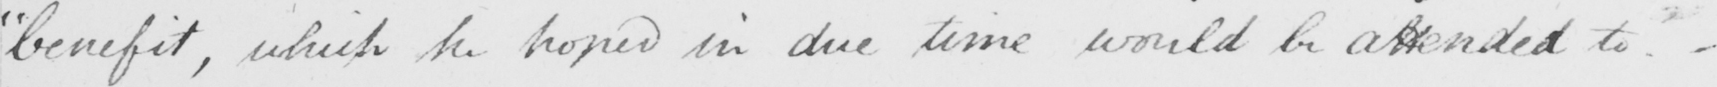What does this handwritten line say? " benefit , which he hoped in due time would be attended to  _ 